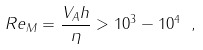Convert formula to latex. <formula><loc_0><loc_0><loc_500><loc_500>R e _ { M } = \frac { V _ { A } h } { \eta } > 1 0 ^ { 3 } - 1 0 ^ { 4 } \ ,</formula> 